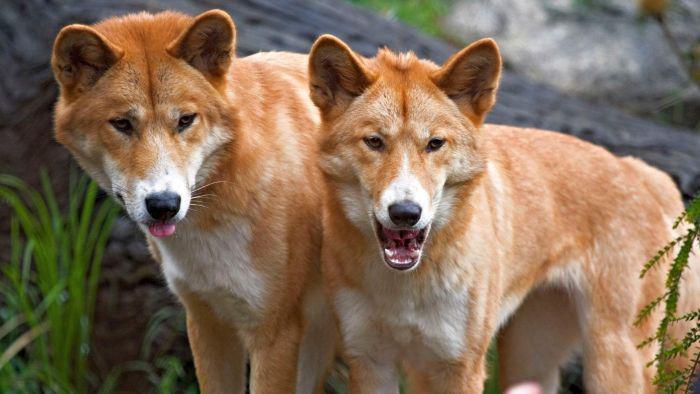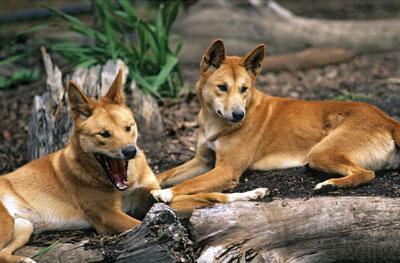The first image is the image on the left, the second image is the image on the right. Given the left and right images, does the statement "There is at least one dingo dog laying down." hold true? Answer yes or no. Yes. The first image is the image on the left, the second image is the image on the right. Evaluate the accuracy of this statement regarding the images: "An image shows a wild dog with its nose pointed toward a rabbit-type animal on green grass.". Is it true? Answer yes or no. No. 